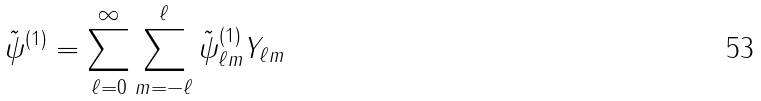Convert formula to latex. <formula><loc_0><loc_0><loc_500><loc_500>\tilde { \psi } ^ { ( 1 ) } = \sum ^ { \infty } _ { \ell = 0 } \sum ^ { \ell } _ { m = - \ell } \tilde { \psi } ^ { ( 1 ) } _ { \ell m } Y _ { \ell m }</formula> 